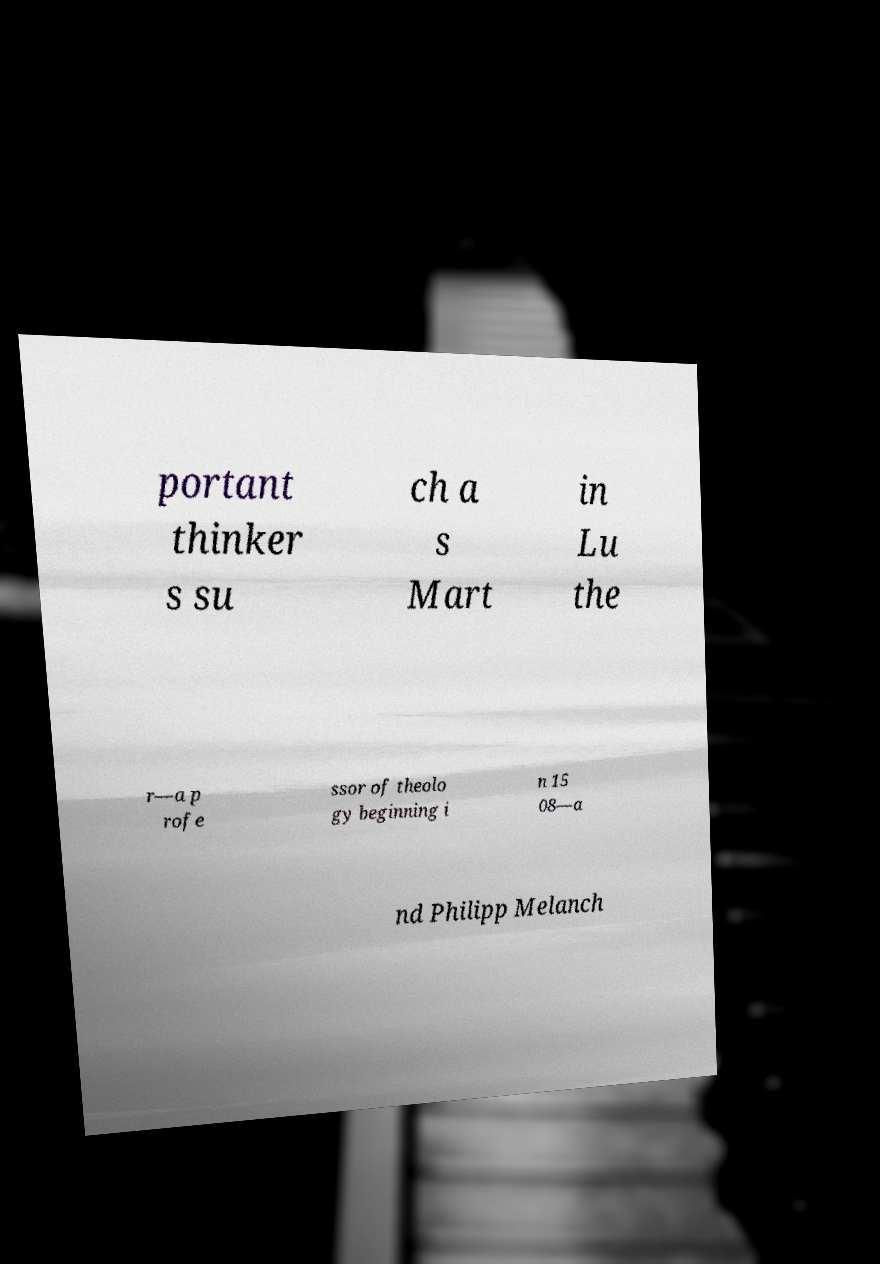Please read and relay the text visible in this image. What does it say? portant thinker s su ch a s Mart in Lu the r—a p rofe ssor of theolo gy beginning i n 15 08—a nd Philipp Melanch 